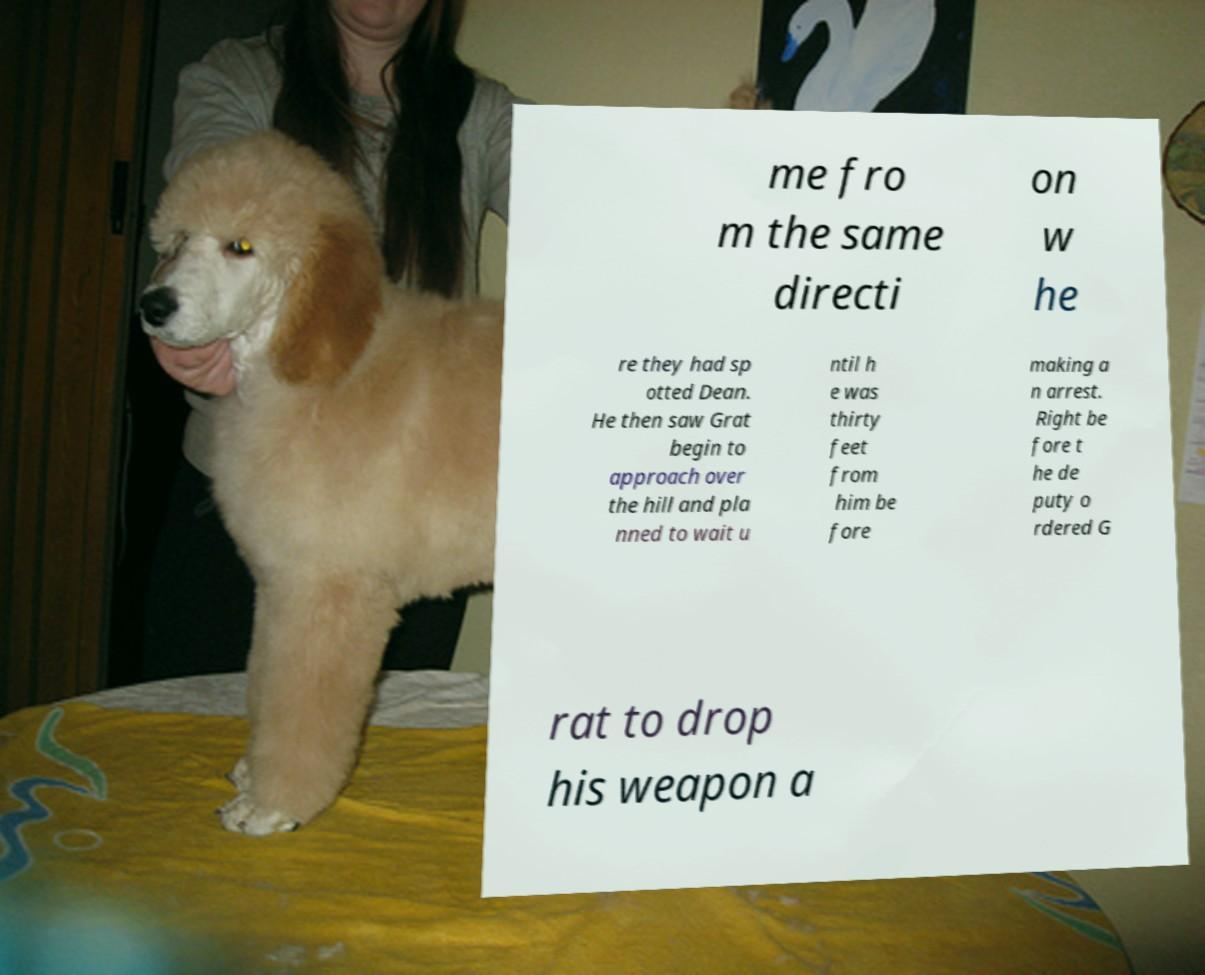Can you accurately transcribe the text from the provided image for me? me fro m the same directi on w he re they had sp otted Dean. He then saw Grat begin to approach over the hill and pla nned to wait u ntil h e was thirty feet from him be fore making a n arrest. Right be fore t he de puty o rdered G rat to drop his weapon a 